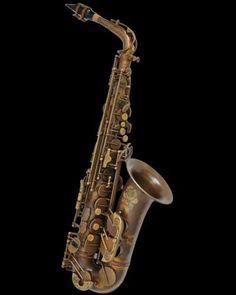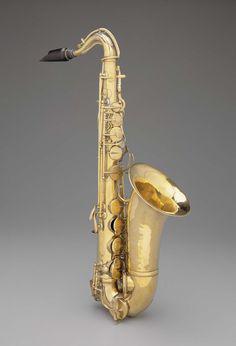The first image is the image on the left, the second image is the image on the right. Given the left and right images, does the statement "Each image contains one saxophone displayed at some angle, with its bell facing rightward, and one image features a silver saxophone with a brown tip at one end." hold true? Answer yes or no. No. 